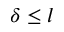Convert formula to latex. <formula><loc_0><loc_0><loc_500><loc_500>\delta \leq l</formula> 